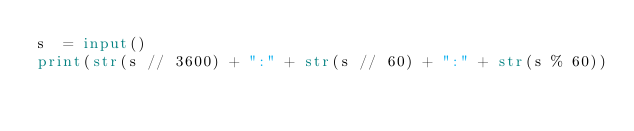<code> <loc_0><loc_0><loc_500><loc_500><_Python_>s  = input()
print(str(s // 3600) + ":" + str(s // 60) + ":" + str(s % 60))</code> 